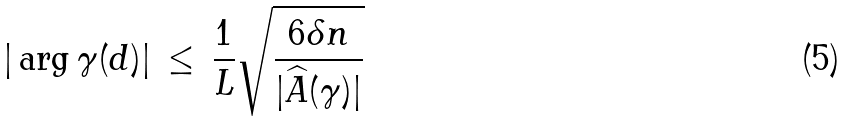<formula> <loc_0><loc_0><loc_500><loc_500>| \arg \gamma ( d ) | \, \leq \, \frac { 1 } { L } \sqrt { \frac { 6 \delta n } { | \widehat { A } ( \gamma ) | } }</formula> 